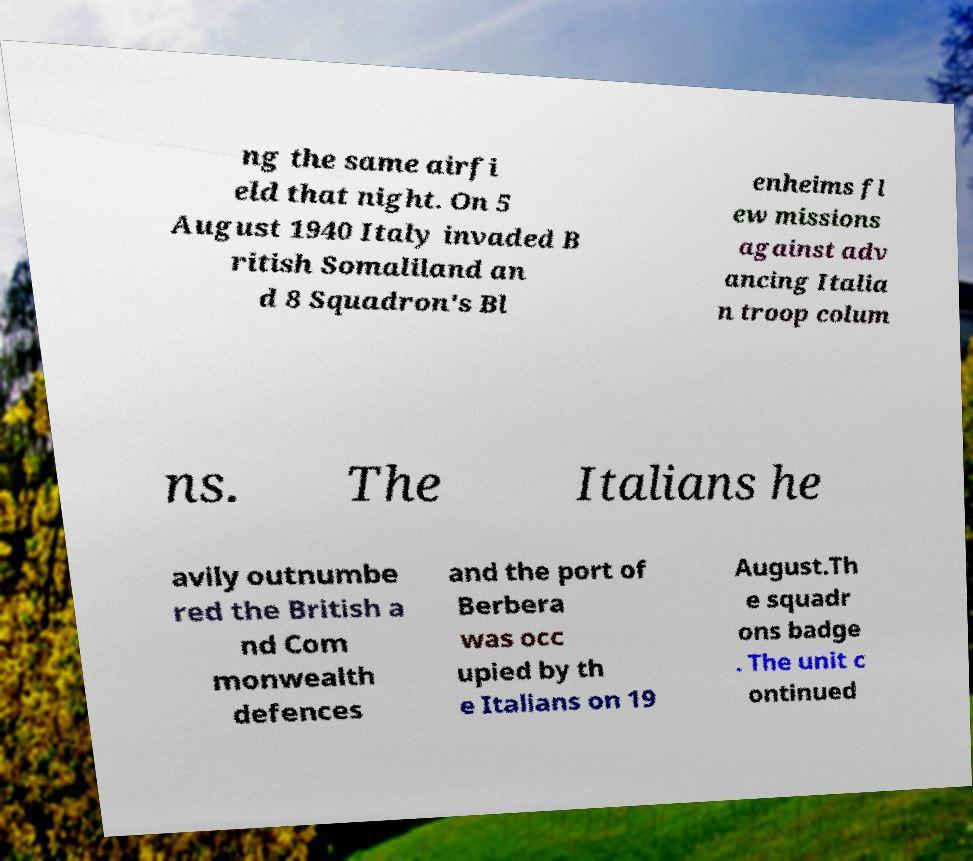Can you read and provide the text displayed in the image?This photo seems to have some interesting text. Can you extract and type it out for me? ng the same airfi eld that night. On 5 August 1940 Italy invaded B ritish Somaliland an d 8 Squadron's Bl enheims fl ew missions against adv ancing Italia n troop colum ns. The Italians he avily outnumbe red the British a nd Com monwealth defences and the port of Berbera was occ upied by th e Italians on 19 August.Th e squadr ons badge . The unit c ontinued 